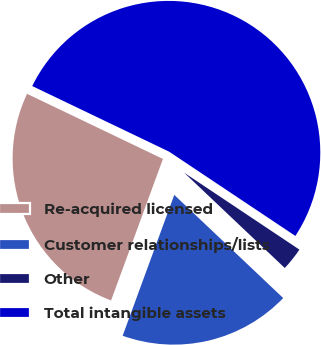Convert chart to OTSL. <chart><loc_0><loc_0><loc_500><loc_500><pie_chart><fcel>Re-acquired licensed<fcel>Customer relationships/lists<fcel>Other<fcel>Total intangible assets<nl><fcel>26.52%<fcel>18.52%<fcel>2.7%<fcel>52.25%<nl></chart> 